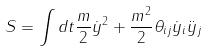<formula> <loc_0><loc_0><loc_500><loc_500>S = \int d t \frac { m } { 2 } \dot { y } ^ { 2 } + \frac { m ^ { 2 } } { 2 } \theta _ { i j } \dot { y } _ { i } \ddot { y } _ { j }</formula> 